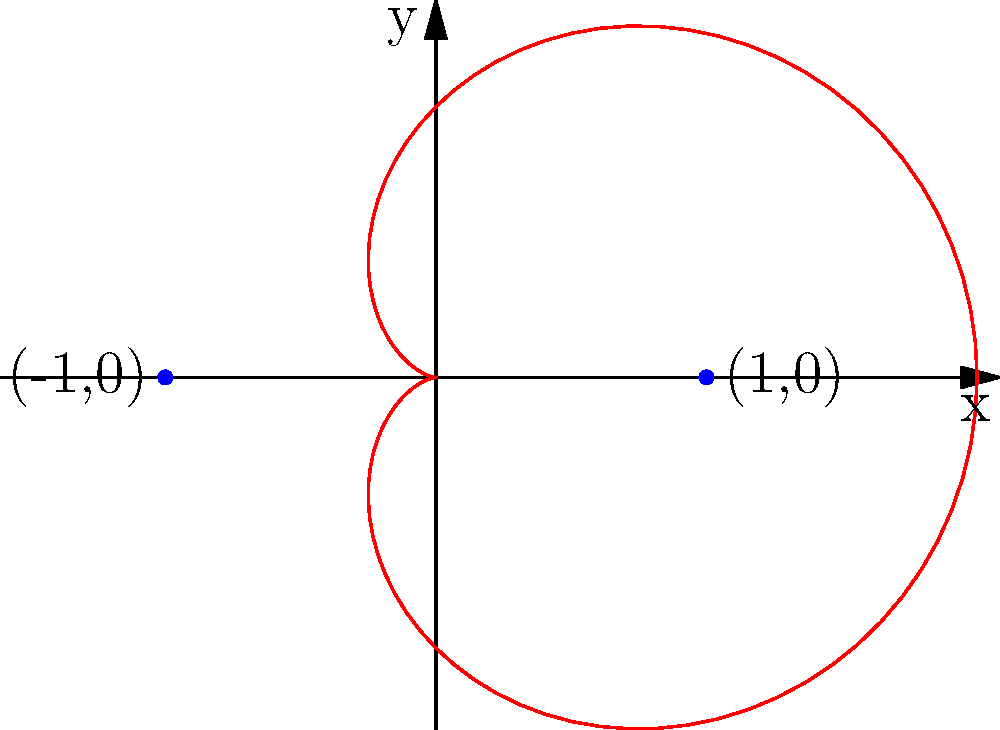Look at the red curve in the polar coordinate system. This shape is called a cardioid. What is the equation of this cardioid in polar form? Let's break this down step-by-step:

1. The cardioid is a heart-shaped curve in polar coordinates.

2. The general equation for a cardioid is:
   $$ r = a(1 \pm \cos(\theta)) \text{ or } r = a(1 \pm \sin(\theta)) $$
   where $a$ is a positive constant.

3. In this graph, we can see that:
   - The curve passes through the point (1,0), which is at $\theta = 0$.
   - The curve touches the y-axis at (0,1) and (0,-1).
   - The leftmost point of the curve is at (-1,0).

4. These observations suggest that $a = 1$ and we're using the cosine form.

5. To determine if it's plus or minus, we need to look at the orientation:
   - The curve has its cusp (pointed end) at (1,0), which means it's using the plus sign.

6. Therefore, the equation of this cardioid is:
   $$ r = 1 + \cos(\theta) $$

This equation means that for any angle $\theta$, the distance from the origin to the curve (r) is equal to 1 plus the cosine of that angle.
Answer: $r = 1 + \cos(\theta)$ 